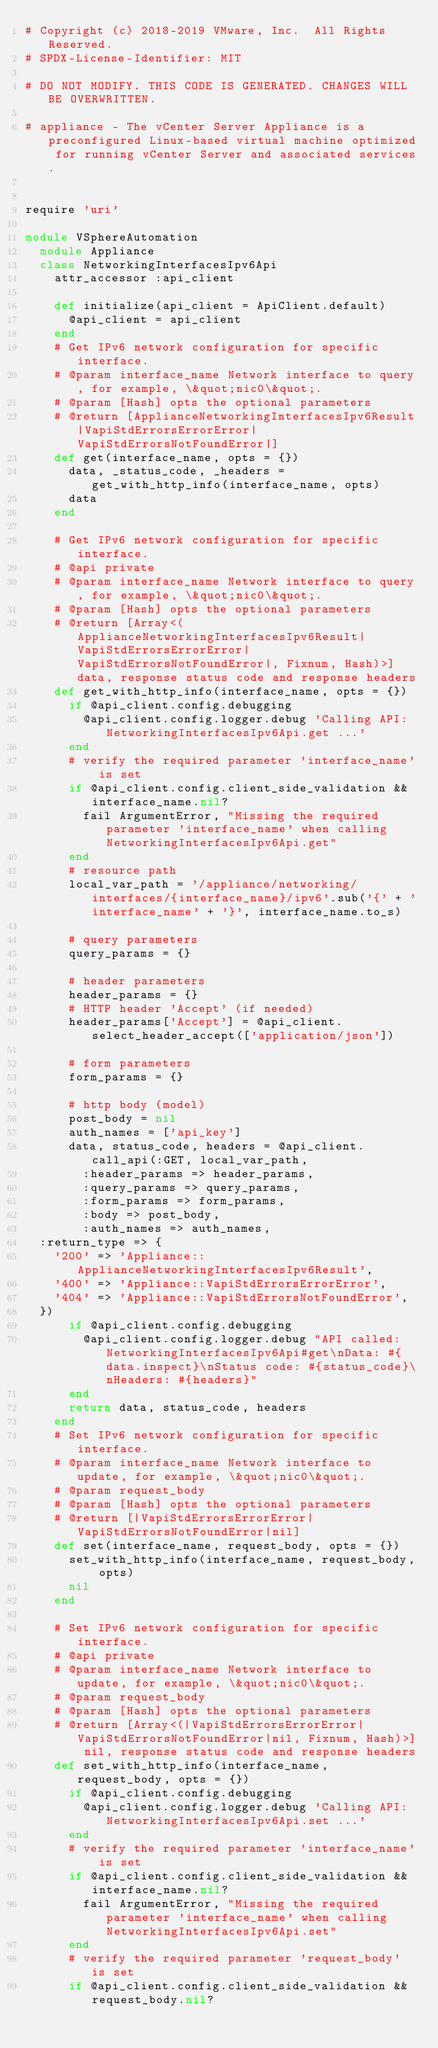Convert code to text. <code><loc_0><loc_0><loc_500><loc_500><_Ruby_># Copyright (c) 2018-2019 VMware, Inc.  All Rights Reserved.
# SPDX-License-Identifier: MIT

# DO NOT MODIFY. THIS CODE IS GENERATED. CHANGES WILL BE OVERWRITTEN.

# appliance - The vCenter Server Appliance is a preconfigured Linux-based virtual machine optimized for running vCenter Server and associated services.


require 'uri'

module VSphereAutomation
  module Appliance
  class NetworkingInterfacesIpv6Api
    attr_accessor :api_client

    def initialize(api_client = ApiClient.default)
      @api_client = api_client
    end
    # Get IPv6 network configuration for specific interface.
    # @param interface_name Network interface to query, for example, \&quot;nic0\&quot;.
    # @param [Hash] opts the optional parameters
    # @return [ApplianceNetworkingInterfacesIpv6Result|VapiStdErrorsErrorError|VapiStdErrorsNotFoundError|]
    def get(interface_name, opts = {})
      data, _status_code, _headers = get_with_http_info(interface_name, opts)
      data
    end

    # Get IPv6 network configuration for specific interface.
    # @api private
    # @param interface_name Network interface to query, for example, \&quot;nic0\&quot;.
    # @param [Hash] opts the optional parameters
    # @return [Array<(ApplianceNetworkingInterfacesIpv6Result|VapiStdErrorsErrorError|VapiStdErrorsNotFoundError|, Fixnum, Hash)>]  data, response status code and response headers
    def get_with_http_info(interface_name, opts = {})
      if @api_client.config.debugging
        @api_client.config.logger.debug 'Calling API: NetworkingInterfacesIpv6Api.get ...'
      end
      # verify the required parameter 'interface_name' is set
      if @api_client.config.client_side_validation && interface_name.nil?
        fail ArgumentError, "Missing the required parameter 'interface_name' when calling NetworkingInterfacesIpv6Api.get"
      end
      # resource path
      local_var_path = '/appliance/networking/interfaces/{interface_name}/ipv6'.sub('{' + 'interface_name' + '}', interface_name.to_s)

      # query parameters
      query_params = {}

      # header parameters
      header_params = {}
      # HTTP header 'Accept' (if needed)
      header_params['Accept'] = @api_client.select_header_accept(['application/json'])

      # form parameters
      form_params = {}

      # http body (model)
      post_body = nil
      auth_names = ['api_key']
      data, status_code, headers = @api_client.call_api(:GET, local_var_path,
        :header_params => header_params,
        :query_params => query_params,
        :form_params => form_params,
        :body => post_body,
        :auth_names => auth_names,
	:return_type => {
	  '200' => 'Appliance::ApplianceNetworkingInterfacesIpv6Result',
	  '400' => 'Appliance::VapiStdErrorsErrorError',
	  '404' => 'Appliance::VapiStdErrorsNotFoundError',
	})
      if @api_client.config.debugging
        @api_client.config.logger.debug "API called: NetworkingInterfacesIpv6Api#get\nData: #{data.inspect}\nStatus code: #{status_code}\nHeaders: #{headers}"
      end
      return data, status_code, headers
    end
    # Set IPv6 network configuration for specific interface.
    # @param interface_name Network interface to update, for example, \&quot;nic0\&quot;.
    # @param request_body 
    # @param [Hash] opts the optional parameters
    # @return [|VapiStdErrorsErrorError|VapiStdErrorsNotFoundError|nil]
    def set(interface_name, request_body, opts = {})
      set_with_http_info(interface_name, request_body, opts)
      nil
    end

    # Set IPv6 network configuration for specific interface.
    # @api private
    # @param interface_name Network interface to update, for example, \&quot;nic0\&quot;.
    # @param request_body 
    # @param [Hash] opts the optional parameters
    # @return [Array<(|VapiStdErrorsErrorError|VapiStdErrorsNotFoundError|nil, Fixnum, Hash)>] nil, response status code and response headers
    def set_with_http_info(interface_name, request_body, opts = {})
      if @api_client.config.debugging
        @api_client.config.logger.debug 'Calling API: NetworkingInterfacesIpv6Api.set ...'
      end
      # verify the required parameter 'interface_name' is set
      if @api_client.config.client_side_validation && interface_name.nil?
        fail ArgumentError, "Missing the required parameter 'interface_name' when calling NetworkingInterfacesIpv6Api.set"
      end
      # verify the required parameter 'request_body' is set
      if @api_client.config.client_side_validation && request_body.nil?</code> 